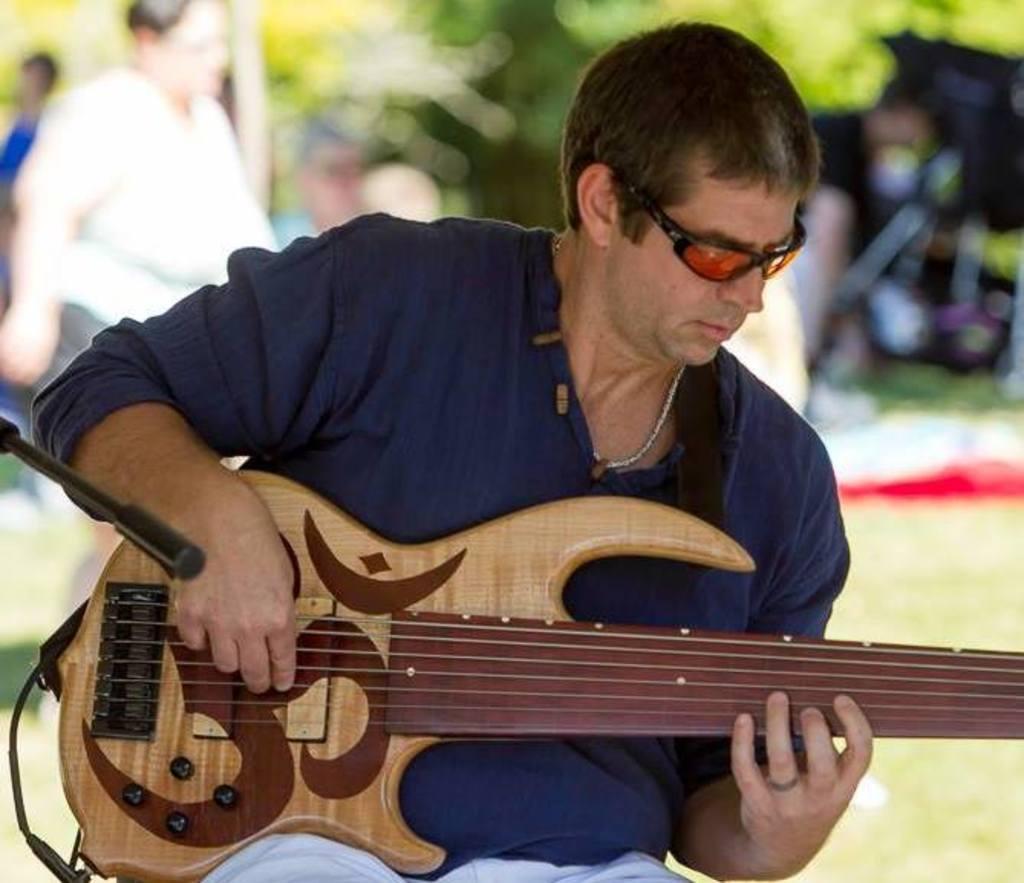Can you describe this image briefly? In this image, in the middle there is a man sitting and he is holding a music instrument which is in yellow color, there is a microphone which is in black color, in the background there is a man walking, there are some green color trees. 